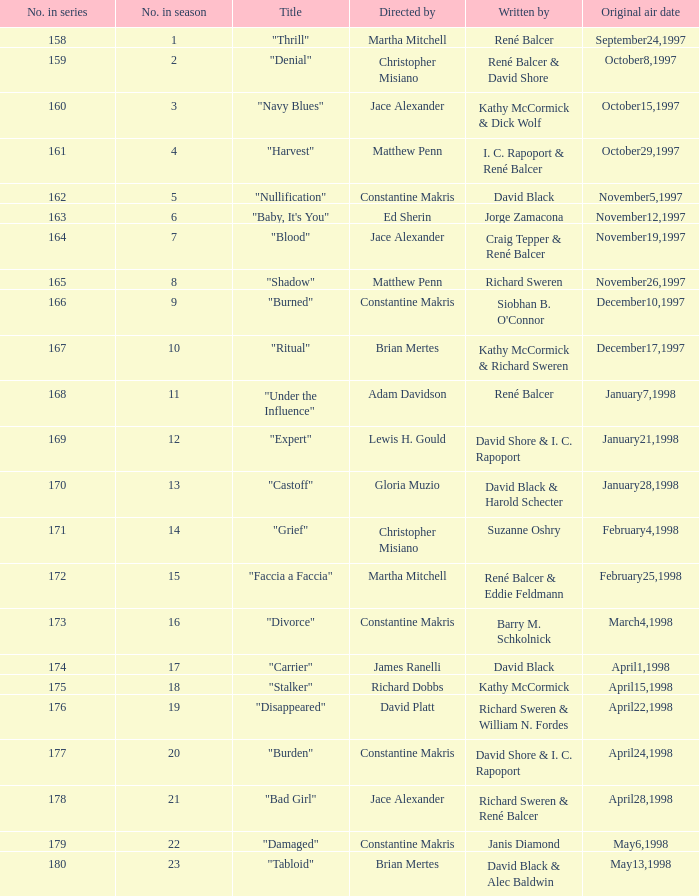The first episode in this season had what number in the series?  158.0. 